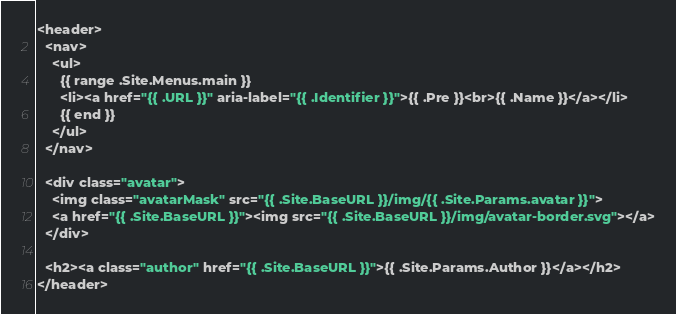<code> <loc_0><loc_0><loc_500><loc_500><_HTML_><header>
  <nav>
    <ul>
      {{ range .Site.Menus.main }}
      <li><a href="{{ .URL }}" aria-label="{{ .Identifier }}">{{ .Pre }}<br>{{ .Name }}</a></li>
      {{ end }}
    </ul>
  </nav>

  <div class="avatar">
    <img class="avatarMask" src="{{ .Site.BaseURL }}/img/{{ .Site.Params.avatar }}">
    <a href="{{ .Site.BaseURL }}"><img src="{{ .Site.BaseURL }}/img/avatar-border.svg"></a>
  </div>

  <h2><a class="author" href="{{ .Site.BaseURL }}">{{ .Site.Params.Author }}</a></h2>
</header>
</code> 